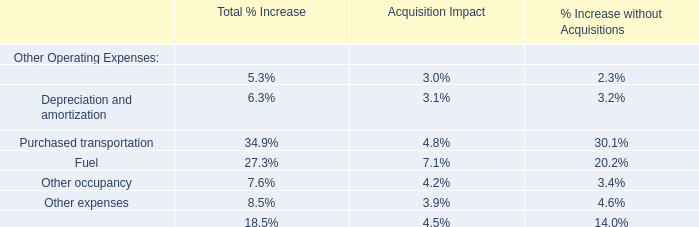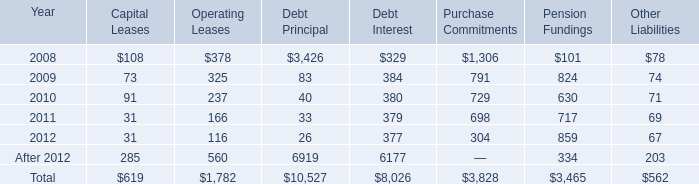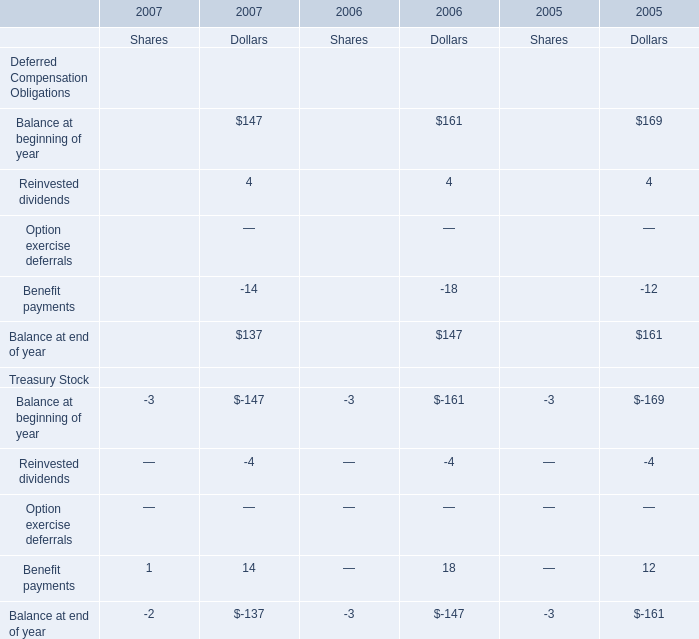What is the percentage of all Balance at end of year that are positive to the total amount, in 2006 for dollars? 
Computations: ((161 + 4) / ((161 + 4) - 18))
Answer: 1.12245. 